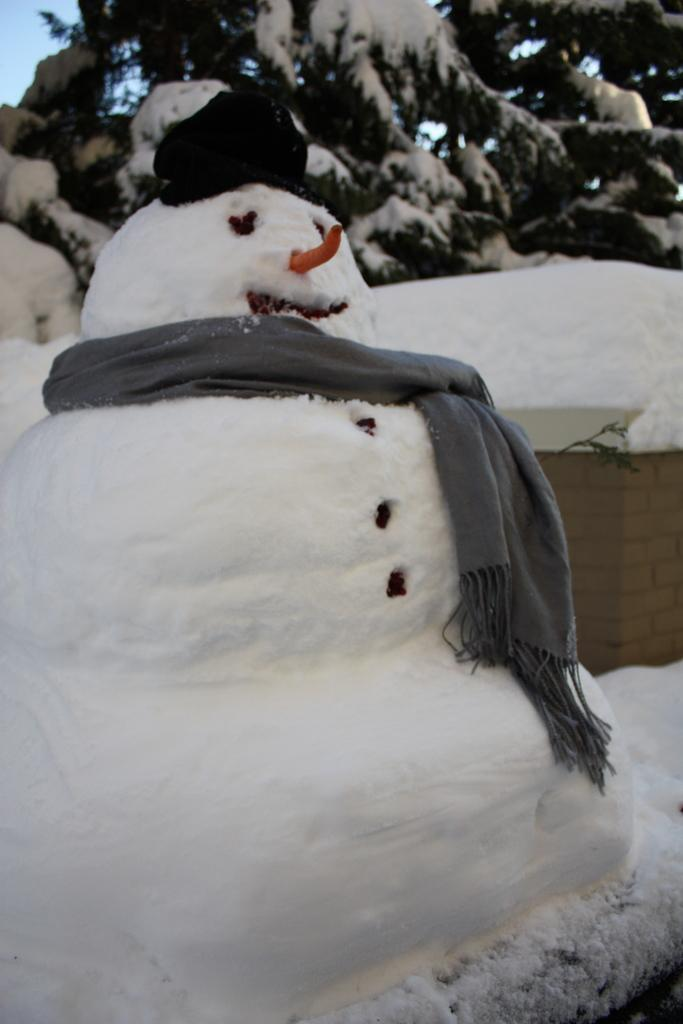What is the main subject of the image? There is a snow doll in the image. Where is the snow doll located? The snow doll is on the surface of the snow. What can be seen in the background of the image? There are trees with snow on them in the background of the image. What part of the natural environment is visible in the image? A part of the sky is visible in the image. What type of wood is used to make the instrument in the image? There is no instrument present in the image. 